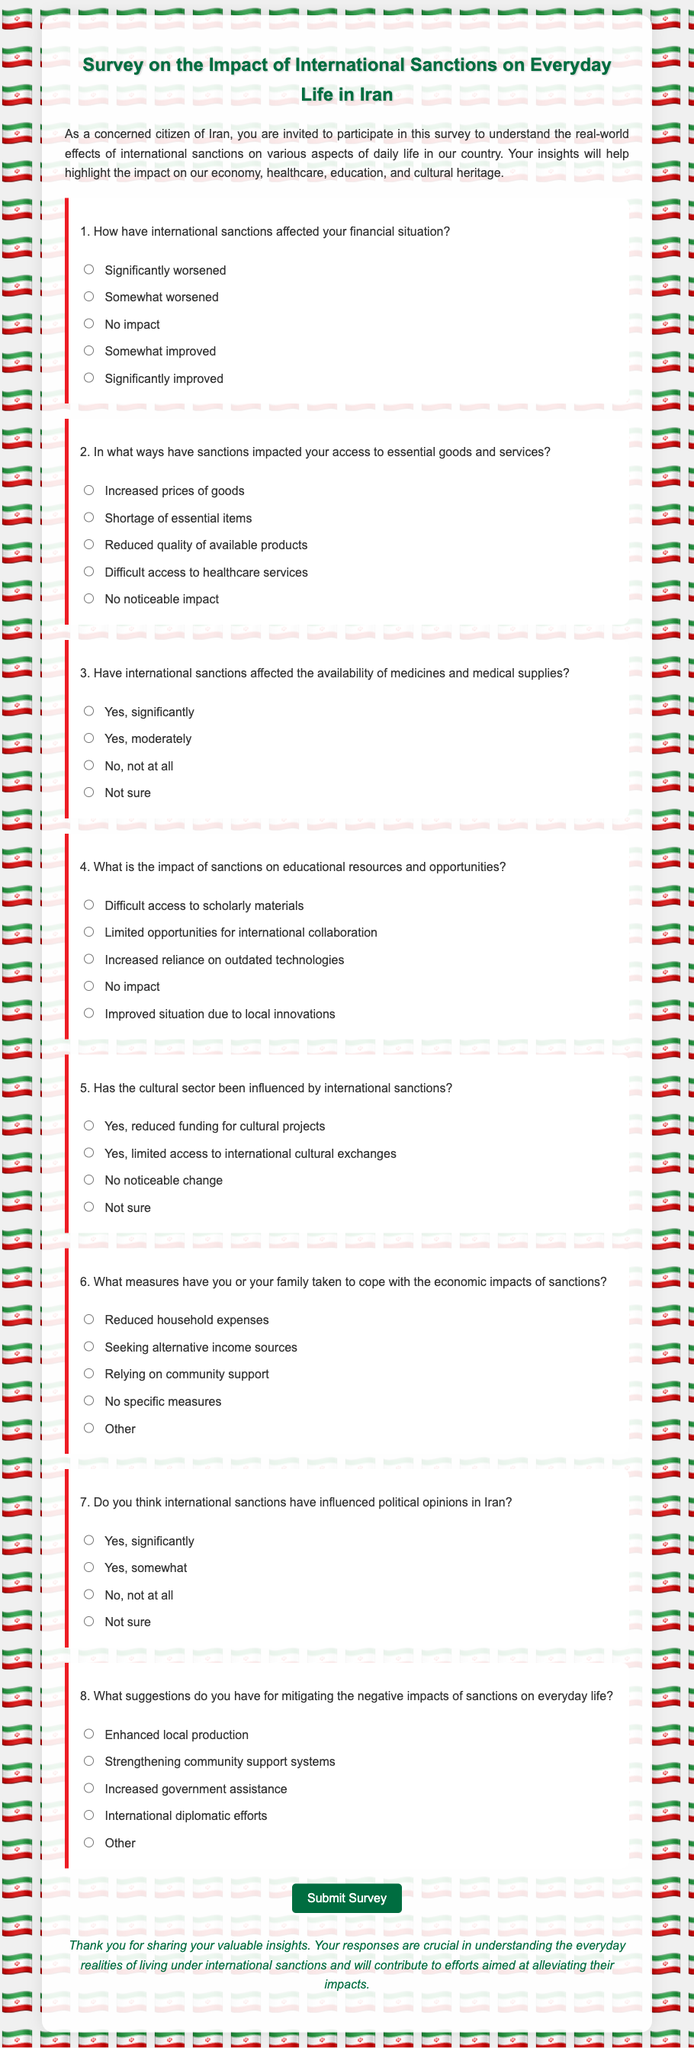What is the title of the survey? The title of the survey is presented at the top of the document.
Answer: Survey on the Impact of International Sanctions on Everyday Life in Iran How many questions are included in the survey? The survey contains a series of questions that are visibly numbered.
Answer: 8 What is the first impact mentioned regarding international sanctions? The first question addresses the financial situation and its relation to sanctions.
Answer: Significantly worsened What option suggests a measure to cope with economic impacts? One of the options in the last question identifies a coping measure.
Answer: Reduced household expenses What is the background color of the survey container? The survey container has a specific background color mentioned in the styling.
Answer: rgba(255, 255, 255, 0.9) What suggestion is made to mitigate negative impacts? The options for suggestions include various strategies to improve the situation.
Answer: Enhanced local production What type of document is this? The document is structured specifically for gathering personal insights through multiple-choice questions.
Answer: Survey form What is the color of the text in the document's body? The color styling applied in the document specifies the text color.
Answer: #333 